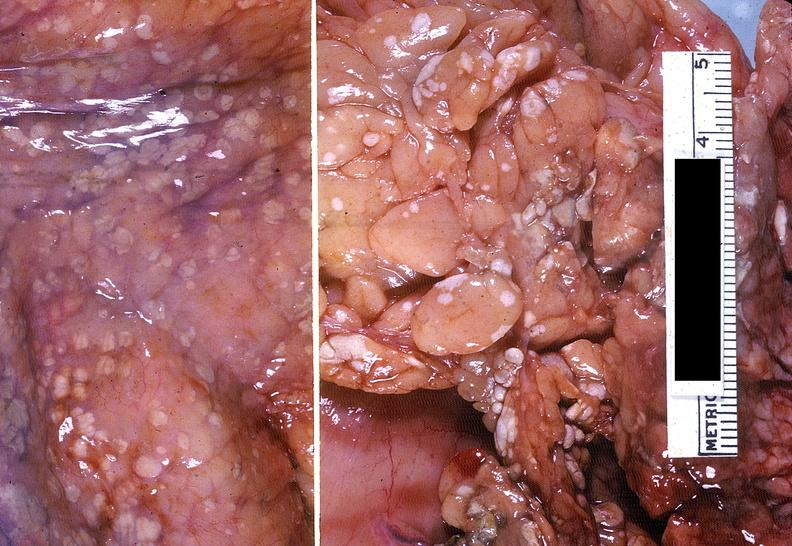does serous cystadenoma show acute pancreatitis with fat necrosis?
Answer the question using a single word or phrase. No 